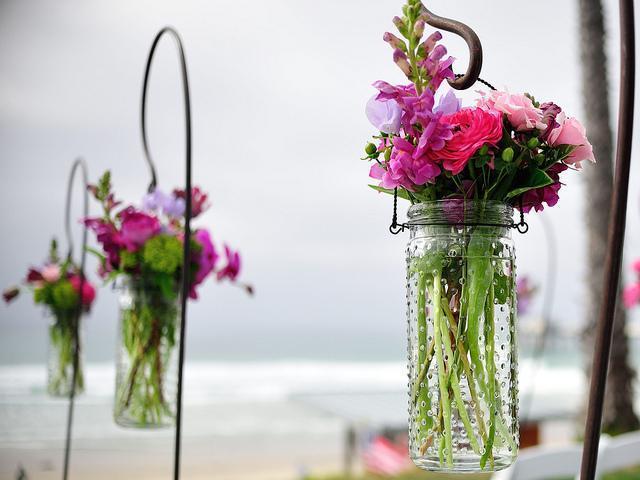How many vases are visible?
Give a very brief answer. 3. How many people are wearing red shirt?
Give a very brief answer. 0. 